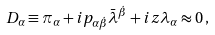<formula> <loc_0><loc_0><loc_500><loc_500>D _ { \alpha } \equiv \pi _ { \alpha } + i p _ { \alpha \dot { \beta } } \bar { \lambda } ^ { \dot { \beta } } + i z \lambda _ { \alpha } \approx 0 \, ,</formula> 